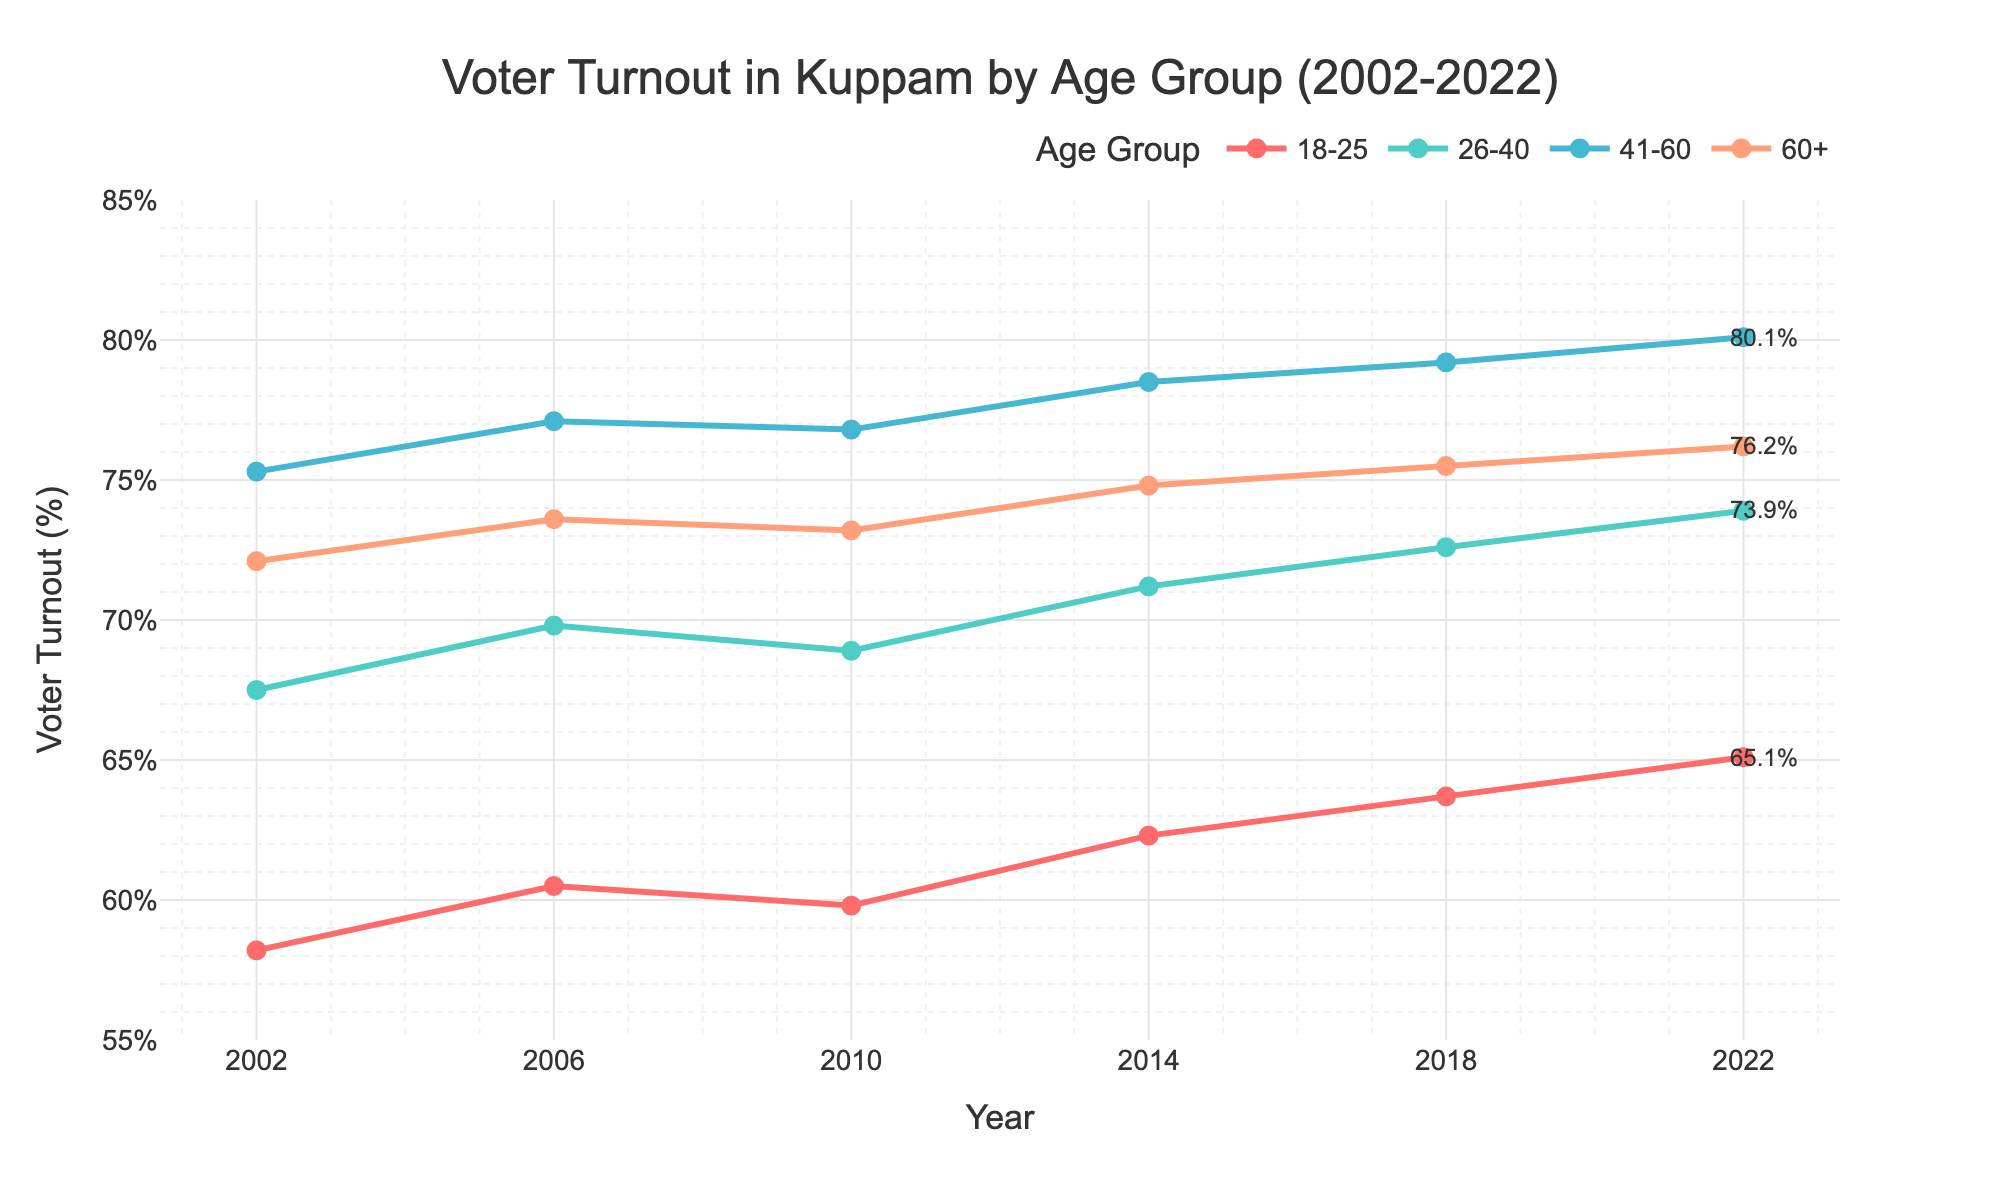What age group had the highest voter turnout percentage in 2022? The plot shows different lines for each age group, with markers indicating the voter turnout percentage over the years. The line representing the 41-60 age group reaches the highest point in 2022.
Answer: 41-60 What was the approximate percentage point increase in voter turnout for the 18-25 age group from 2002 to 2022? The voter turnout for the 18-25 age group was 58.2% in 2002 and increased to 65.1% in 2022. The difference between these two values is 65.1 - 58.2.
Answer: 6.9 How did the voter turnout for the 60+ age group change from 2010 to 2018? In 2010, the voter turnout for the 60+ age group was 73.2%, and in 2018 it was 75.5%. Subtracting the earlier value from the later one gives the change: 75.5 - 73.2.
Answer: 2.3 Which age group had the least variability in voter turnout over the 20 years? Observing the lines on the chart, the 18-25 age group exhibits the smallest fluctuations in voter turnout percentage.
Answer: 18-25 What is the average voter turnout for the 26-40 age group across all years presented? To find the average, add the voter turnout percentages for the 26-40 age group across all given years: (67.5 + 69.8 + 68.9 + 71.2 + 72.6 + 73.9) and then divide by the number of years (6). The sum is 423.9, and dividing this by 6 gives the average.
Answer: 70.65 Which year showed the smallest difference in voter turnout between the 18-25 and 26-40 age groups? By examining each year, we calculate the differences between the voter turnout percentages for the 18-25 and 26-40 age groups. In 2010, the difference is smallest at 68.9 - 59.8 = 9.1.
Answer: 2010 Is there a consistent trend of increasing voter turnout for any age group? Reviewing the lines, the 26-40 and 41-60 age groups have a consistent upward trend in voter turnout percentages from 2002 to 2022.
Answer: Yes 